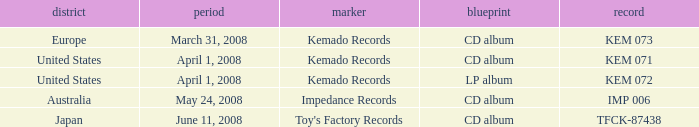Which Label has a Region of united states, and a Format of lp album? Kemado Records. 